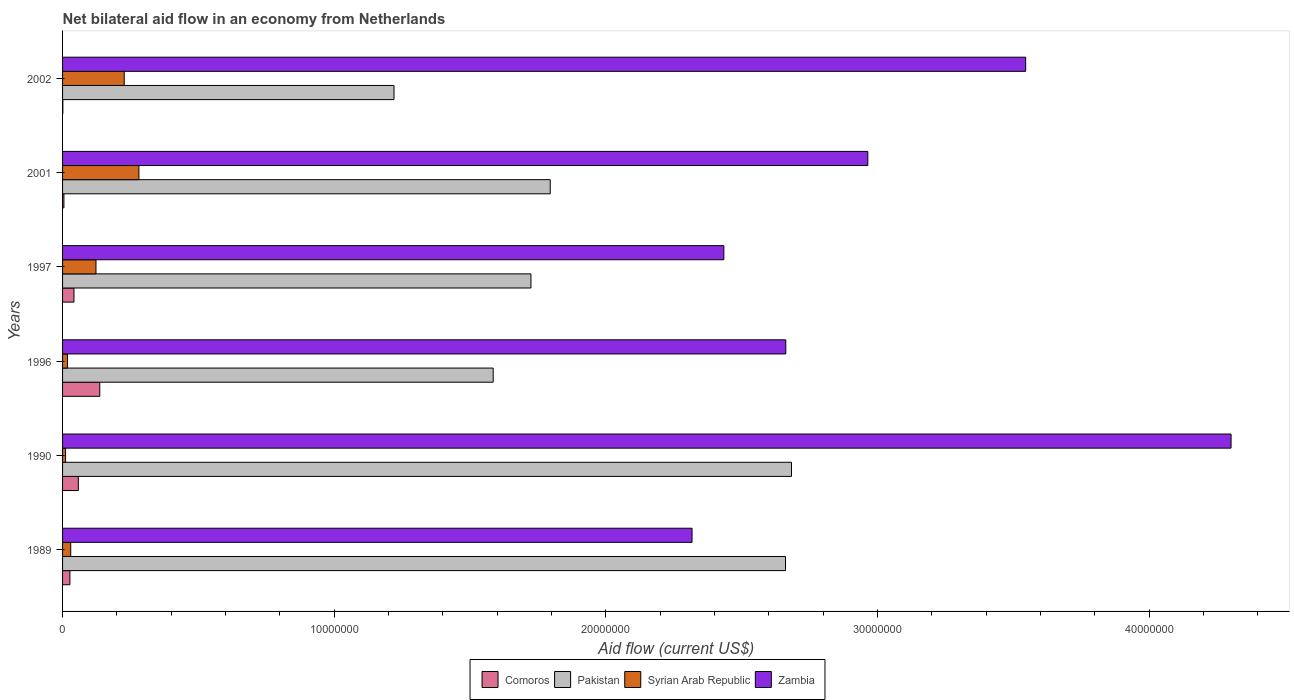How many different coloured bars are there?
Your answer should be very brief. 4. How many groups of bars are there?
Make the answer very short. 6. Are the number of bars per tick equal to the number of legend labels?
Ensure brevity in your answer.  Yes. Are the number of bars on each tick of the Y-axis equal?
Ensure brevity in your answer.  Yes. Across all years, what is the maximum net bilateral aid flow in Zambia?
Provide a succinct answer. 4.30e+07. In which year was the net bilateral aid flow in Syrian Arab Republic maximum?
Make the answer very short. 2001. What is the total net bilateral aid flow in Comoros in the graph?
Provide a short and direct response. 2.70e+06. What is the difference between the net bilateral aid flow in Zambia in 1990 and that in 2002?
Ensure brevity in your answer.  7.56e+06. What is the difference between the net bilateral aid flow in Zambia in 1997 and the net bilateral aid flow in Pakistan in 2001?
Provide a short and direct response. 6.39e+06. What is the average net bilateral aid flow in Comoros per year?
Provide a succinct answer. 4.50e+05. In the year 1989, what is the difference between the net bilateral aid flow in Pakistan and net bilateral aid flow in Syrian Arab Republic?
Make the answer very short. 2.63e+07. In how many years, is the net bilateral aid flow in Zambia greater than 30000000 US$?
Your response must be concise. 2. What is the ratio of the net bilateral aid flow in Comoros in 1990 to that in 1996?
Your answer should be very brief. 0.42. Is the net bilateral aid flow in Zambia in 1996 less than that in 2002?
Your answer should be compact. Yes. Is the difference between the net bilateral aid flow in Pakistan in 1997 and 2001 greater than the difference between the net bilateral aid flow in Syrian Arab Republic in 1997 and 2001?
Provide a short and direct response. Yes. What is the difference between the highest and the second highest net bilateral aid flow in Zambia?
Provide a short and direct response. 7.56e+06. What is the difference between the highest and the lowest net bilateral aid flow in Zambia?
Give a very brief answer. 1.98e+07. In how many years, is the net bilateral aid flow in Zambia greater than the average net bilateral aid flow in Zambia taken over all years?
Give a very brief answer. 2. Is it the case that in every year, the sum of the net bilateral aid flow in Pakistan and net bilateral aid flow in Zambia is greater than the sum of net bilateral aid flow in Comoros and net bilateral aid flow in Syrian Arab Republic?
Your response must be concise. Yes. What does the 2nd bar from the top in 2002 represents?
Offer a terse response. Syrian Arab Republic. What does the 1st bar from the bottom in 1996 represents?
Provide a succinct answer. Comoros. Is it the case that in every year, the sum of the net bilateral aid flow in Comoros and net bilateral aid flow in Zambia is greater than the net bilateral aid flow in Pakistan?
Offer a terse response. No. How many bars are there?
Provide a succinct answer. 24. Are all the bars in the graph horizontal?
Your answer should be very brief. Yes. How many years are there in the graph?
Give a very brief answer. 6. Does the graph contain any zero values?
Your answer should be very brief. No. Does the graph contain grids?
Offer a very short reply. No. Where does the legend appear in the graph?
Provide a short and direct response. Bottom center. What is the title of the graph?
Keep it short and to the point. Net bilateral aid flow in an economy from Netherlands. What is the label or title of the X-axis?
Offer a terse response. Aid flow (current US$). What is the Aid flow (current US$) in Pakistan in 1989?
Provide a succinct answer. 2.66e+07. What is the Aid flow (current US$) of Zambia in 1989?
Offer a very short reply. 2.32e+07. What is the Aid flow (current US$) in Comoros in 1990?
Keep it short and to the point. 5.80e+05. What is the Aid flow (current US$) of Pakistan in 1990?
Your response must be concise. 2.68e+07. What is the Aid flow (current US$) of Syrian Arab Republic in 1990?
Your answer should be compact. 1.10e+05. What is the Aid flow (current US$) of Zambia in 1990?
Give a very brief answer. 4.30e+07. What is the Aid flow (current US$) of Comoros in 1996?
Provide a succinct answer. 1.37e+06. What is the Aid flow (current US$) in Pakistan in 1996?
Offer a terse response. 1.58e+07. What is the Aid flow (current US$) in Syrian Arab Republic in 1996?
Keep it short and to the point. 1.80e+05. What is the Aid flow (current US$) of Zambia in 1996?
Your answer should be compact. 2.66e+07. What is the Aid flow (current US$) of Pakistan in 1997?
Offer a very short reply. 1.72e+07. What is the Aid flow (current US$) of Syrian Arab Republic in 1997?
Make the answer very short. 1.23e+06. What is the Aid flow (current US$) of Zambia in 1997?
Make the answer very short. 2.43e+07. What is the Aid flow (current US$) of Pakistan in 2001?
Your answer should be compact. 1.80e+07. What is the Aid flow (current US$) in Syrian Arab Republic in 2001?
Your answer should be very brief. 2.81e+06. What is the Aid flow (current US$) of Zambia in 2001?
Provide a succinct answer. 2.96e+07. What is the Aid flow (current US$) in Pakistan in 2002?
Give a very brief answer. 1.22e+07. What is the Aid flow (current US$) of Syrian Arab Republic in 2002?
Keep it short and to the point. 2.27e+06. What is the Aid flow (current US$) of Zambia in 2002?
Your answer should be compact. 3.54e+07. Across all years, what is the maximum Aid flow (current US$) in Comoros?
Provide a short and direct response. 1.37e+06. Across all years, what is the maximum Aid flow (current US$) in Pakistan?
Your answer should be compact. 2.68e+07. Across all years, what is the maximum Aid flow (current US$) in Syrian Arab Republic?
Provide a succinct answer. 2.81e+06. Across all years, what is the maximum Aid flow (current US$) of Zambia?
Keep it short and to the point. 4.30e+07. Across all years, what is the minimum Aid flow (current US$) in Comoros?
Offer a terse response. 10000. Across all years, what is the minimum Aid flow (current US$) in Pakistan?
Provide a short and direct response. 1.22e+07. Across all years, what is the minimum Aid flow (current US$) of Zambia?
Provide a short and direct response. 2.32e+07. What is the total Aid flow (current US$) of Comoros in the graph?
Your answer should be compact. 2.70e+06. What is the total Aid flow (current US$) in Pakistan in the graph?
Provide a succinct answer. 1.17e+08. What is the total Aid flow (current US$) in Syrian Arab Republic in the graph?
Ensure brevity in your answer.  6.90e+06. What is the total Aid flow (current US$) of Zambia in the graph?
Offer a terse response. 1.82e+08. What is the difference between the Aid flow (current US$) of Comoros in 1989 and that in 1990?
Provide a short and direct response. -3.10e+05. What is the difference between the Aid flow (current US$) in Pakistan in 1989 and that in 1990?
Keep it short and to the point. -2.20e+05. What is the difference between the Aid flow (current US$) in Syrian Arab Republic in 1989 and that in 1990?
Your answer should be very brief. 1.90e+05. What is the difference between the Aid flow (current US$) in Zambia in 1989 and that in 1990?
Offer a very short reply. -1.98e+07. What is the difference between the Aid flow (current US$) in Comoros in 1989 and that in 1996?
Your answer should be compact. -1.10e+06. What is the difference between the Aid flow (current US$) in Pakistan in 1989 and that in 1996?
Provide a short and direct response. 1.08e+07. What is the difference between the Aid flow (current US$) of Syrian Arab Republic in 1989 and that in 1996?
Your answer should be very brief. 1.20e+05. What is the difference between the Aid flow (current US$) in Zambia in 1989 and that in 1996?
Offer a very short reply. -3.45e+06. What is the difference between the Aid flow (current US$) of Pakistan in 1989 and that in 1997?
Offer a very short reply. 9.37e+06. What is the difference between the Aid flow (current US$) of Syrian Arab Republic in 1989 and that in 1997?
Your response must be concise. -9.30e+05. What is the difference between the Aid flow (current US$) of Zambia in 1989 and that in 1997?
Make the answer very short. -1.17e+06. What is the difference between the Aid flow (current US$) in Pakistan in 1989 and that in 2001?
Provide a short and direct response. 8.66e+06. What is the difference between the Aid flow (current US$) of Syrian Arab Republic in 1989 and that in 2001?
Your response must be concise. -2.51e+06. What is the difference between the Aid flow (current US$) of Zambia in 1989 and that in 2001?
Offer a very short reply. -6.47e+06. What is the difference between the Aid flow (current US$) in Pakistan in 1989 and that in 2002?
Ensure brevity in your answer.  1.44e+07. What is the difference between the Aid flow (current US$) in Syrian Arab Republic in 1989 and that in 2002?
Make the answer very short. -1.97e+06. What is the difference between the Aid flow (current US$) in Zambia in 1989 and that in 2002?
Ensure brevity in your answer.  -1.23e+07. What is the difference between the Aid flow (current US$) of Comoros in 1990 and that in 1996?
Make the answer very short. -7.90e+05. What is the difference between the Aid flow (current US$) in Pakistan in 1990 and that in 1996?
Provide a succinct answer. 1.10e+07. What is the difference between the Aid flow (current US$) of Syrian Arab Republic in 1990 and that in 1996?
Your response must be concise. -7.00e+04. What is the difference between the Aid flow (current US$) in Zambia in 1990 and that in 1996?
Provide a succinct answer. 1.64e+07. What is the difference between the Aid flow (current US$) of Comoros in 1990 and that in 1997?
Offer a terse response. 1.60e+05. What is the difference between the Aid flow (current US$) of Pakistan in 1990 and that in 1997?
Give a very brief answer. 9.59e+06. What is the difference between the Aid flow (current US$) of Syrian Arab Republic in 1990 and that in 1997?
Your response must be concise. -1.12e+06. What is the difference between the Aid flow (current US$) of Zambia in 1990 and that in 1997?
Offer a terse response. 1.87e+07. What is the difference between the Aid flow (current US$) of Comoros in 1990 and that in 2001?
Make the answer very short. 5.30e+05. What is the difference between the Aid flow (current US$) of Pakistan in 1990 and that in 2001?
Offer a very short reply. 8.88e+06. What is the difference between the Aid flow (current US$) of Syrian Arab Republic in 1990 and that in 2001?
Provide a short and direct response. -2.70e+06. What is the difference between the Aid flow (current US$) of Zambia in 1990 and that in 2001?
Ensure brevity in your answer.  1.34e+07. What is the difference between the Aid flow (current US$) of Comoros in 1990 and that in 2002?
Offer a very short reply. 5.70e+05. What is the difference between the Aid flow (current US$) of Pakistan in 1990 and that in 2002?
Keep it short and to the point. 1.46e+07. What is the difference between the Aid flow (current US$) of Syrian Arab Republic in 1990 and that in 2002?
Provide a succinct answer. -2.16e+06. What is the difference between the Aid flow (current US$) of Zambia in 1990 and that in 2002?
Give a very brief answer. 7.56e+06. What is the difference between the Aid flow (current US$) in Comoros in 1996 and that in 1997?
Make the answer very short. 9.50e+05. What is the difference between the Aid flow (current US$) in Pakistan in 1996 and that in 1997?
Make the answer very short. -1.39e+06. What is the difference between the Aid flow (current US$) of Syrian Arab Republic in 1996 and that in 1997?
Offer a terse response. -1.05e+06. What is the difference between the Aid flow (current US$) in Zambia in 1996 and that in 1997?
Offer a very short reply. 2.28e+06. What is the difference between the Aid flow (current US$) of Comoros in 1996 and that in 2001?
Your answer should be very brief. 1.32e+06. What is the difference between the Aid flow (current US$) in Pakistan in 1996 and that in 2001?
Provide a short and direct response. -2.10e+06. What is the difference between the Aid flow (current US$) of Syrian Arab Republic in 1996 and that in 2001?
Your response must be concise. -2.63e+06. What is the difference between the Aid flow (current US$) in Zambia in 1996 and that in 2001?
Give a very brief answer. -3.02e+06. What is the difference between the Aid flow (current US$) in Comoros in 1996 and that in 2002?
Offer a terse response. 1.36e+06. What is the difference between the Aid flow (current US$) in Pakistan in 1996 and that in 2002?
Your response must be concise. 3.65e+06. What is the difference between the Aid flow (current US$) in Syrian Arab Republic in 1996 and that in 2002?
Your answer should be compact. -2.09e+06. What is the difference between the Aid flow (current US$) of Zambia in 1996 and that in 2002?
Ensure brevity in your answer.  -8.83e+06. What is the difference between the Aid flow (current US$) of Comoros in 1997 and that in 2001?
Offer a terse response. 3.70e+05. What is the difference between the Aid flow (current US$) in Pakistan in 1997 and that in 2001?
Ensure brevity in your answer.  -7.10e+05. What is the difference between the Aid flow (current US$) in Syrian Arab Republic in 1997 and that in 2001?
Your answer should be compact. -1.58e+06. What is the difference between the Aid flow (current US$) of Zambia in 1997 and that in 2001?
Your response must be concise. -5.30e+06. What is the difference between the Aid flow (current US$) in Comoros in 1997 and that in 2002?
Provide a short and direct response. 4.10e+05. What is the difference between the Aid flow (current US$) of Pakistan in 1997 and that in 2002?
Your answer should be compact. 5.04e+06. What is the difference between the Aid flow (current US$) of Syrian Arab Republic in 1997 and that in 2002?
Your answer should be compact. -1.04e+06. What is the difference between the Aid flow (current US$) of Zambia in 1997 and that in 2002?
Your answer should be compact. -1.11e+07. What is the difference between the Aid flow (current US$) of Comoros in 2001 and that in 2002?
Keep it short and to the point. 4.00e+04. What is the difference between the Aid flow (current US$) in Pakistan in 2001 and that in 2002?
Offer a terse response. 5.75e+06. What is the difference between the Aid flow (current US$) of Syrian Arab Republic in 2001 and that in 2002?
Make the answer very short. 5.40e+05. What is the difference between the Aid flow (current US$) of Zambia in 2001 and that in 2002?
Your answer should be very brief. -5.81e+06. What is the difference between the Aid flow (current US$) in Comoros in 1989 and the Aid flow (current US$) in Pakistan in 1990?
Provide a short and direct response. -2.66e+07. What is the difference between the Aid flow (current US$) of Comoros in 1989 and the Aid flow (current US$) of Zambia in 1990?
Your answer should be compact. -4.27e+07. What is the difference between the Aid flow (current US$) in Pakistan in 1989 and the Aid flow (current US$) in Syrian Arab Republic in 1990?
Provide a short and direct response. 2.65e+07. What is the difference between the Aid flow (current US$) of Pakistan in 1989 and the Aid flow (current US$) of Zambia in 1990?
Keep it short and to the point. -1.64e+07. What is the difference between the Aid flow (current US$) in Syrian Arab Republic in 1989 and the Aid flow (current US$) in Zambia in 1990?
Make the answer very short. -4.27e+07. What is the difference between the Aid flow (current US$) in Comoros in 1989 and the Aid flow (current US$) in Pakistan in 1996?
Give a very brief answer. -1.56e+07. What is the difference between the Aid flow (current US$) in Comoros in 1989 and the Aid flow (current US$) in Zambia in 1996?
Your answer should be compact. -2.64e+07. What is the difference between the Aid flow (current US$) of Pakistan in 1989 and the Aid flow (current US$) of Syrian Arab Republic in 1996?
Provide a short and direct response. 2.64e+07. What is the difference between the Aid flow (current US$) in Syrian Arab Republic in 1989 and the Aid flow (current US$) in Zambia in 1996?
Your response must be concise. -2.63e+07. What is the difference between the Aid flow (current US$) in Comoros in 1989 and the Aid flow (current US$) in Pakistan in 1997?
Your answer should be very brief. -1.70e+07. What is the difference between the Aid flow (current US$) of Comoros in 1989 and the Aid flow (current US$) of Syrian Arab Republic in 1997?
Ensure brevity in your answer.  -9.60e+05. What is the difference between the Aid flow (current US$) in Comoros in 1989 and the Aid flow (current US$) in Zambia in 1997?
Offer a terse response. -2.41e+07. What is the difference between the Aid flow (current US$) of Pakistan in 1989 and the Aid flow (current US$) of Syrian Arab Republic in 1997?
Ensure brevity in your answer.  2.54e+07. What is the difference between the Aid flow (current US$) of Pakistan in 1989 and the Aid flow (current US$) of Zambia in 1997?
Your answer should be very brief. 2.27e+06. What is the difference between the Aid flow (current US$) in Syrian Arab Republic in 1989 and the Aid flow (current US$) in Zambia in 1997?
Offer a terse response. -2.40e+07. What is the difference between the Aid flow (current US$) in Comoros in 1989 and the Aid flow (current US$) in Pakistan in 2001?
Provide a succinct answer. -1.77e+07. What is the difference between the Aid flow (current US$) in Comoros in 1989 and the Aid flow (current US$) in Syrian Arab Republic in 2001?
Your answer should be very brief. -2.54e+06. What is the difference between the Aid flow (current US$) in Comoros in 1989 and the Aid flow (current US$) in Zambia in 2001?
Make the answer very short. -2.94e+07. What is the difference between the Aid flow (current US$) in Pakistan in 1989 and the Aid flow (current US$) in Syrian Arab Republic in 2001?
Your answer should be compact. 2.38e+07. What is the difference between the Aid flow (current US$) of Pakistan in 1989 and the Aid flow (current US$) of Zambia in 2001?
Your answer should be compact. -3.03e+06. What is the difference between the Aid flow (current US$) in Syrian Arab Republic in 1989 and the Aid flow (current US$) in Zambia in 2001?
Offer a terse response. -2.93e+07. What is the difference between the Aid flow (current US$) in Comoros in 1989 and the Aid flow (current US$) in Pakistan in 2002?
Ensure brevity in your answer.  -1.19e+07. What is the difference between the Aid flow (current US$) in Comoros in 1989 and the Aid flow (current US$) in Zambia in 2002?
Ensure brevity in your answer.  -3.52e+07. What is the difference between the Aid flow (current US$) in Pakistan in 1989 and the Aid flow (current US$) in Syrian Arab Republic in 2002?
Ensure brevity in your answer.  2.43e+07. What is the difference between the Aid flow (current US$) of Pakistan in 1989 and the Aid flow (current US$) of Zambia in 2002?
Give a very brief answer. -8.84e+06. What is the difference between the Aid flow (current US$) of Syrian Arab Republic in 1989 and the Aid flow (current US$) of Zambia in 2002?
Make the answer very short. -3.52e+07. What is the difference between the Aid flow (current US$) of Comoros in 1990 and the Aid flow (current US$) of Pakistan in 1996?
Give a very brief answer. -1.53e+07. What is the difference between the Aid flow (current US$) in Comoros in 1990 and the Aid flow (current US$) in Syrian Arab Republic in 1996?
Provide a short and direct response. 4.00e+05. What is the difference between the Aid flow (current US$) in Comoros in 1990 and the Aid flow (current US$) in Zambia in 1996?
Offer a very short reply. -2.60e+07. What is the difference between the Aid flow (current US$) of Pakistan in 1990 and the Aid flow (current US$) of Syrian Arab Republic in 1996?
Provide a short and direct response. 2.66e+07. What is the difference between the Aid flow (current US$) in Pakistan in 1990 and the Aid flow (current US$) in Zambia in 1996?
Your answer should be very brief. 2.10e+05. What is the difference between the Aid flow (current US$) in Syrian Arab Republic in 1990 and the Aid flow (current US$) in Zambia in 1996?
Offer a terse response. -2.65e+07. What is the difference between the Aid flow (current US$) of Comoros in 1990 and the Aid flow (current US$) of Pakistan in 1997?
Offer a terse response. -1.67e+07. What is the difference between the Aid flow (current US$) of Comoros in 1990 and the Aid flow (current US$) of Syrian Arab Republic in 1997?
Provide a succinct answer. -6.50e+05. What is the difference between the Aid flow (current US$) of Comoros in 1990 and the Aid flow (current US$) of Zambia in 1997?
Keep it short and to the point. -2.38e+07. What is the difference between the Aid flow (current US$) in Pakistan in 1990 and the Aid flow (current US$) in Syrian Arab Republic in 1997?
Keep it short and to the point. 2.56e+07. What is the difference between the Aid flow (current US$) of Pakistan in 1990 and the Aid flow (current US$) of Zambia in 1997?
Ensure brevity in your answer.  2.49e+06. What is the difference between the Aid flow (current US$) in Syrian Arab Republic in 1990 and the Aid flow (current US$) in Zambia in 1997?
Keep it short and to the point. -2.42e+07. What is the difference between the Aid flow (current US$) of Comoros in 1990 and the Aid flow (current US$) of Pakistan in 2001?
Your response must be concise. -1.74e+07. What is the difference between the Aid flow (current US$) in Comoros in 1990 and the Aid flow (current US$) in Syrian Arab Republic in 2001?
Offer a very short reply. -2.23e+06. What is the difference between the Aid flow (current US$) of Comoros in 1990 and the Aid flow (current US$) of Zambia in 2001?
Your answer should be very brief. -2.91e+07. What is the difference between the Aid flow (current US$) in Pakistan in 1990 and the Aid flow (current US$) in Syrian Arab Republic in 2001?
Ensure brevity in your answer.  2.40e+07. What is the difference between the Aid flow (current US$) in Pakistan in 1990 and the Aid flow (current US$) in Zambia in 2001?
Provide a short and direct response. -2.81e+06. What is the difference between the Aid flow (current US$) of Syrian Arab Republic in 1990 and the Aid flow (current US$) of Zambia in 2001?
Make the answer very short. -2.95e+07. What is the difference between the Aid flow (current US$) of Comoros in 1990 and the Aid flow (current US$) of Pakistan in 2002?
Offer a terse response. -1.16e+07. What is the difference between the Aid flow (current US$) of Comoros in 1990 and the Aid flow (current US$) of Syrian Arab Republic in 2002?
Offer a terse response. -1.69e+06. What is the difference between the Aid flow (current US$) of Comoros in 1990 and the Aid flow (current US$) of Zambia in 2002?
Provide a short and direct response. -3.49e+07. What is the difference between the Aid flow (current US$) of Pakistan in 1990 and the Aid flow (current US$) of Syrian Arab Republic in 2002?
Ensure brevity in your answer.  2.46e+07. What is the difference between the Aid flow (current US$) in Pakistan in 1990 and the Aid flow (current US$) in Zambia in 2002?
Offer a very short reply. -8.62e+06. What is the difference between the Aid flow (current US$) in Syrian Arab Republic in 1990 and the Aid flow (current US$) in Zambia in 2002?
Provide a short and direct response. -3.53e+07. What is the difference between the Aid flow (current US$) of Comoros in 1996 and the Aid flow (current US$) of Pakistan in 1997?
Offer a very short reply. -1.59e+07. What is the difference between the Aid flow (current US$) in Comoros in 1996 and the Aid flow (current US$) in Zambia in 1997?
Your answer should be compact. -2.30e+07. What is the difference between the Aid flow (current US$) of Pakistan in 1996 and the Aid flow (current US$) of Syrian Arab Republic in 1997?
Your response must be concise. 1.46e+07. What is the difference between the Aid flow (current US$) in Pakistan in 1996 and the Aid flow (current US$) in Zambia in 1997?
Provide a short and direct response. -8.49e+06. What is the difference between the Aid flow (current US$) of Syrian Arab Republic in 1996 and the Aid flow (current US$) of Zambia in 1997?
Provide a short and direct response. -2.42e+07. What is the difference between the Aid flow (current US$) in Comoros in 1996 and the Aid flow (current US$) in Pakistan in 2001?
Ensure brevity in your answer.  -1.66e+07. What is the difference between the Aid flow (current US$) of Comoros in 1996 and the Aid flow (current US$) of Syrian Arab Republic in 2001?
Offer a very short reply. -1.44e+06. What is the difference between the Aid flow (current US$) of Comoros in 1996 and the Aid flow (current US$) of Zambia in 2001?
Your response must be concise. -2.83e+07. What is the difference between the Aid flow (current US$) in Pakistan in 1996 and the Aid flow (current US$) in Syrian Arab Republic in 2001?
Make the answer very short. 1.30e+07. What is the difference between the Aid flow (current US$) of Pakistan in 1996 and the Aid flow (current US$) of Zambia in 2001?
Provide a succinct answer. -1.38e+07. What is the difference between the Aid flow (current US$) of Syrian Arab Republic in 1996 and the Aid flow (current US$) of Zambia in 2001?
Offer a very short reply. -2.95e+07. What is the difference between the Aid flow (current US$) of Comoros in 1996 and the Aid flow (current US$) of Pakistan in 2002?
Offer a terse response. -1.08e+07. What is the difference between the Aid flow (current US$) in Comoros in 1996 and the Aid flow (current US$) in Syrian Arab Republic in 2002?
Your answer should be compact. -9.00e+05. What is the difference between the Aid flow (current US$) of Comoros in 1996 and the Aid flow (current US$) of Zambia in 2002?
Offer a terse response. -3.41e+07. What is the difference between the Aid flow (current US$) in Pakistan in 1996 and the Aid flow (current US$) in Syrian Arab Republic in 2002?
Your answer should be very brief. 1.36e+07. What is the difference between the Aid flow (current US$) in Pakistan in 1996 and the Aid flow (current US$) in Zambia in 2002?
Make the answer very short. -1.96e+07. What is the difference between the Aid flow (current US$) of Syrian Arab Republic in 1996 and the Aid flow (current US$) of Zambia in 2002?
Make the answer very short. -3.53e+07. What is the difference between the Aid flow (current US$) of Comoros in 1997 and the Aid flow (current US$) of Pakistan in 2001?
Ensure brevity in your answer.  -1.75e+07. What is the difference between the Aid flow (current US$) of Comoros in 1997 and the Aid flow (current US$) of Syrian Arab Republic in 2001?
Give a very brief answer. -2.39e+06. What is the difference between the Aid flow (current US$) in Comoros in 1997 and the Aid flow (current US$) in Zambia in 2001?
Offer a terse response. -2.92e+07. What is the difference between the Aid flow (current US$) of Pakistan in 1997 and the Aid flow (current US$) of Syrian Arab Republic in 2001?
Offer a very short reply. 1.44e+07. What is the difference between the Aid flow (current US$) in Pakistan in 1997 and the Aid flow (current US$) in Zambia in 2001?
Make the answer very short. -1.24e+07. What is the difference between the Aid flow (current US$) in Syrian Arab Republic in 1997 and the Aid flow (current US$) in Zambia in 2001?
Provide a succinct answer. -2.84e+07. What is the difference between the Aid flow (current US$) in Comoros in 1997 and the Aid flow (current US$) in Pakistan in 2002?
Make the answer very short. -1.18e+07. What is the difference between the Aid flow (current US$) of Comoros in 1997 and the Aid flow (current US$) of Syrian Arab Republic in 2002?
Give a very brief answer. -1.85e+06. What is the difference between the Aid flow (current US$) in Comoros in 1997 and the Aid flow (current US$) in Zambia in 2002?
Keep it short and to the point. -3.50e+07. What is the difference between the Aid flow (current US$) in Pakistan in 1997 and the Aid flow (current US$) in Syrian Arab Republic in 2002?
Make the answer very short. 1.50e+07. What is the difference between the Aid flow (current US$) of Pakistan in 1997 and the Aid flow (current US$) of Zambia in 2002?
Your answer should be very brief. -1.82e+07. What is the difference between the Aid flow (current US$) of Syrian Arab Republic in 1997 and the Aid flow (current US$) of Zambia in 2002?
Give a very brief answer. -3.42e+07. What is the difference between the Aid flow (current US$) of Comoros in 2001 and the Aid flow (current US$) of Pakistan in 2002?
Ensure brevity in your answer.  -1.22e+07. What is the difference between the Aid flow (current US$) of Comoros in 2001 and the Aid flow (current US$) of Syrian Arab Republic in 2002?
Your response must be concise. -2.22e+06. What is the difference between the Aid flow (current US$) of Comoros in 2001 and the Aid flow (current US$) of Zambia in 2002?
Offer a terse response. -3.54e+07. What is the difference between the Aid flow (current US$) in Pakistan in 2001 and the Aid flow (current US$) in Syrian Arab Republic in 2002?
Ensure brevity in your answer.  1.57e+07. What is the difference between the Aid flow (current US$) of Pakistan in 2001 and the Aid flow (current US$) of Zambia in 2002?
Provide a succinct answer. -1.75e+07. What is the difference between the Aid flow (current US$) in Syrian Arab Republic in 2001 and the Aid flow (current US$) in Zambia in 2002?
Your answer should be very brief. -3.26e+07. What is the average Aid flow (current US$) in Comoros per year?
Offer a very short reply. 4.50e+05. What is the average Aid flow (current US$) of Pakistan per year?
Provide a short and direct response. 1.94e+07. What is the average Aid flow (current US$) of Syrian Arab Republic per year?
Provide a short and direct response. 1.15e+06. What is the average Aid flow (current US$) of Zambia per year?
Provide a succinct answer. 3.04e+07. In the year 1989, what is the difference between the Aid flow (current US$) of Comoros and Aid flow (current US$) of Pakistan?
Your response must be concise. -2.63e+07. In the year 1989, what is the difference between the Aid flow (current US$) in Comoros and Aid flow (current US$) in Syrian Arab Republic?
Provide a succinct answer. -3.00e+04. In the year 1989, what is the difference between the Aid flow (current US$) in Comoros and Aid flow (current US$) in Zambia?
Offer a terse response. -2.29e+07. In the year 1989, what is the difference between the Aid flow (current US$) in Pakistan and Aid flow (current US$) in Syrian Arab Republic?
Make the answer very short. 2.63e+07. In the year 1989, what is the difference between the Aid flow (current US$) of Pakistan and Aid flow (current US$) of Zambia?
Offer a terse response. 3.44e+06. In the year 1989, what is the difference between the Aid flow (current US$) of Syrian Arab Republic and Aid flow (current US$) of Zambia?
Offer a terse response. -2.29e+07. In the year 1990, what is the difference between the Aid flow (current US$) of Comoros and Aid flow (current US$) of Pakistan?
Give a very brief answer. -2.62e+07. In the year 1990, what is the difference between the Aid flow (current US$) in Comoros and Aid flow (current US$) in Zambia?
Give a very brief answer. -4.24e+07. In the year 1990, what is the difference between the Aid flow (current US$) of Pakistan and Aid flow (current US$) of Syrian Arab Republic?
Provide a succinct answer. 2.67e+07. In the year 1990, what is the difference between the Aid flow (current US$) of Pakistan and Aid flow (current US$) of Zambia?
Ensure brevity in your answer.  -1.62e+07. In the year 1990, what is the difference between the Aid flow (current US$) in Syrian Arab Republic and Aid flow (current US$) in Zambia?
Your answer should be very brief. -4.29e+07. In the year 1996, what is the difference between the Aid flow (current US$) of Comoros and Aid flow (current US$) of Pakistan?
Offer a very short reply. -1.45e+07. In the year 1996, what is the difference between the Aid flow (current US$) of Comoros and Aid flow (current US$) of Syrian Arab Republic?
Your answer should be compact. 1.19e+06. In the year 1996, what is the difference between the Aid flow (current US$) in Comoros and Aid flow (current US$) in Zambia?
Your answer should be compact. -2.52e+07. In the year 1996, what is the difference between the Aid flow (current US$) in Pakistan and Aid flow (current US$) in Syrian Arab Republic?
Keep it short and to the point. 1.57e+07. In the year 1996, what is the difference between the Aid flow (current US$) in Pakistan and Aid flow (current US$) in Zambia?
Provide a short and direct response. -1.08e+07. In the year 1996, what is the difference between the Aid flow (current US$) of Syrian Arab Republic and Aid flow (current US$) of Zambia?
Provide a succinct answer. -2.64e+07. In the year 1997, what is the difference between the Aid flow (current US$) of Comoros and Aid flow (current US$) of Pakistan?
Provide a short and direct response. -1.68e+07. In the year 1997, what is the difference between the Aid flow (current US$) of Comoros and Aid flow (current US$) of Syrian Arab Republic?
Provide a short and direct response. -8.10e+05. In the year 1997, what is the difference between the Aid flow (current US$) of Comoros and Aid flow (current US$) of Zambia?
Ensure brevity in your answer.  -2.39e+07. In the year 1997, what is the difference between the Aid flow (current US$) of Pakistan and Aid flow (current US$) of Syrian Arab Republic?
Make the answer very short. 1.60e+07. In the year 1997, what is the difference between the Aid flow (current US$) in Pakistan and Aid flow (current US$) in Zambia?
Offer a terse response. -7.10e+06. In the year 1997, what is the difference between the Aid flow (current US$) of Syrian Arab Republic and Aid flow (current US$) of Zambia?
Make the answer very short. -2.31e+07. In the year 2001, what is the difference between the Aid flow (current US$) of Comoros and Aid flow (current US$) of Pakistan?
Make the answer very short. -1.79e+07. In the year 2001, what is the difference between the Aid flow (current US$) in Comoros and Aid flow (current US$) in Syrian Arab Republic?
Your answer should be compact. -2.76e+06. In the year 2001, what is the difference between the Aid flow (current US$) of Comoros and Aid flow (current US$) of Zambia?
Provide a succinct answer. -2.96e+07. In the year 2001, what is the difference between the Aid flow (current US$) of Pakistan and Aid flow (current US$) of Syrian Arab Republic?
Provide a short and direct response. 1.51e+07. In the year 2001, what is the difference between the Aid flow (current US$) of Pakistan and Aid flow (current US$) of Zambia?
Provide a short and direct response. -1.17e+07. In the year 2001, what is the difference between the Aid flow (current US$) of Syrian Arab Republic and Aid flow (current US$) of Zambia?
Keep it short and to the point. -2.68e+07. In the year 2002, what is the difference between the Aid flow (current US$) in Comoros and Aid flow (current US$) in Pakistan?
Provide a succinct answer. -1.22e+07. In the year 2002, what is the difference between the Aid flow (current US$) of Comoros and Aid flow (current US$) of Syrian Arab Republic?
Give a very brief answer. -2.26e+06. In the year 2002, what is the difference between the Aid flow (current US$) in Comoros and Aid flow (current US$) in Zambia?
Provide a short and direct response. -3.54e+07. In the year 2002, what is the difference between the Aid flow (current US$) in Pakistan and Aid flow (current US$) in Syrian Arab Republic?
Keep it short and to the point. 9.93e+06. In the year 2002, what is the difference between the Aid flow (current US$) of Pakistan and Aid flow (current US$) of Zambia?
Your response must be concise. -2.32e+07. In the year 2002, what is the difference between the Aid flow (current US$) of Syrian Arab Republic and Aid flow (current US$) of Zambia?
Your response must be concise. -3.32e+07. What is the ratio of the Aid flow (current US$) of Comoros in 1989 to that in 1990?
Make the answer very short. 0.47. What is the ratio of the Aid flow (current US$) in Pakistan in 1989 to that in 1990?
Make the answer very short. 0.99. What is the ratio of the Aid flow (current US$) of Syrian Arab Republic in 1989 to that in 1990?
Give a very brief answer. 2.73. What is the ratio of the Aid flow (current US$) of Zambia in 1989 to that in 1990?
Offer a very short reply. 0.54. What is the ratio of the Aid flow (current US$) of Comoros in 1989 to that in 1996?
Your response must be concise. 0.2. What is the ratio of the Aid flow (current US$) in Pakistan in 1989 to that in 1996?
Provide a succinct answer. 1.68. What is the ratio of the Aid flow (current US$) of Syrian Arab Republic in 1989 to that in 1996?
Ensure brevity in your answer.  1.67. What is the ratio of the Aid flow (current US$) in Zambia in 1989 to that in 1996?
Offer a terse response. 0.87. What is the ratio of the Aid flow (current US$) in Comoros in 1989 to that in 1997?
Your answer should be compact. 0.64. What is the ratio of the Aid flow (current US$) of Pakistan in 1989 to that in 1997?
Offer a terse response. 1.54. What is the ratio of the Aid flow (current US$) of Syrian Arab Republic in 1989 to that in 1997?
Offer a terse response. 0.24. What is the ratio of the Aid flow (current US$) in Zambia in 1989 to that in 1997?
Provide a short and direct response. 0.95. What is the ratio of the Aid flow (current US$) of Comoros in 1989 to that in 2001?
Give a very brief answer. 5.4. What is the ratio of the Aid flow (current US$) of Pakistan in 1989 to that in 2001?
Your response must be concise. 1.48. What is the ratio of the Aid flow (current US$) in Syrian Arab Republic in 1989 to that in 2001?
Make the answer very short. 0.11. What is the ratio of the Aid flow (current US$) in Zambia in 1989 to that in 2001?
Provide a short and direct response. 0.78. What is the ratio of the Aid flow (current US$) in Comoros in 1989 to that in 2002?
Make the answer very short. 27. What is the ratio of the Aid flow (current US$) in Pakistan in 1989 to that in 2002?
Offer a very short reply. 2.18. What is the ratio of the Aid flow (current US$) of Syrian Arab Republic in 1989 to that in 2002?
Provide a succinct answer. 0.13. What is the ratio of the Aid flow (current US$) of Zambia in 1989 to that in 2002?
Provide a succinct answer. 0.65. What is the ratio of the Aid flow (current US$) of Comoros in 1990 to that in 1996?
Provide a succinct answer. 0.42. What is the ratio of the Aid flow (current US$) in Pakistan in 1990 to that in 1996?
Your answer should be very brief. 1.69. What is the ratio of the Aid flow (current US$) of Syrian Arab Republic in 1990 to that in 1996?
Give a very brief answer. 0.61. What is the ratio of the Aid flow (current US$) in Zambia in 1990 to that in 1996?
Your answer should be compact. 1.62. What is the ratio of the Aid flow (current US$) in Comoros in 1990 to that in 1997?
Offer a terse response. 1.38. What is the ratio of the Aid flow (current US$) of Pakistan in 1990 to that in 1997?
Provide a short and direct response. 1.56. What is the ratio of the Aid flow (current US$) of Syrian Arab Republic in 1990 to that in 1997?
Your response must be concise. 0.09. What is the ratio of the Aid flow (current US$) in Zambia in 1990 to that in 1997?
Ensure brevity in your answer.  1.77. What is the ratio of the Aid flow (current US$) in Pakistan in 1990 to that in 2001?
Offer a terse response. 1.49. What is the ratio of the Aid flow (current US$) in Syrian Arab Republic in 1990 to that in 2001?
Your answer should be compact. 0.04. What is the ratio of the Aid flow (current US$) in Zambia in 1990 to that in 2001?
Ensure brevity in your answer.  1.45. What is the ratio of the Aid flow (current US$) of Pakistan in 1990 to that in 2002?
Keep it short and to the point. 2.2. What is the ratio of the Aid flow (current US$) of Syrian Arab Republic in 1990 to that in 2002?
Your answer should be compact. 0.05. What is the ratio of the Aid flow (current US$) in Zambia in 1990 to that in 2002?
Ensure brevity in your answer.  1.21. What is the ratio of the Aid flow (current US$) of Comoros in 1996 to that in 1997?
Make the answer very short. 3.26. What is the ratio of the Aid flow (current US$) in Pakistan in 1996 to that in 1997?
Provide a short and direct response. 0.92. What is the ratio of the Aid flow (current US$) in Syrian Arab Republic in 1996 to that in 1997?
Ensure brevity in your answer.  0.15. What is the ratio of the Aid flow (current US$) of Zambia in 1996 to that in 1997?
Provide a succinct answer. 1.09. What is the ratio of the Aid flow (current US$) in Comoros in 1996 to that in 2001?
Make the answer very short. 27.4. What is the ratio of the Aid flow (current US$) of Pakistan in 1996 to that in 2001?
Provide a short and direct response. 0.88. What is the ratio of the Aid flow (current US$) in Syrian Arab Republic in 1996 to that in 2001?
Keep it short and to the point. 0.06. What is the ratio of the Aid flow (current US$) of Zambia in 1996 to that in 2001?
Your answer should be very brief. 0.9. What is the ratio of the Aid flow (current US$) of Comoros in 1996 to that in 2002?
Provide a short and direct response. 137. What is the ratio of the Aid flow (current US$) of Pakistan in 1996 to that in 2002?
Offer a very short reply. 1.3. What is the ratio of the Aid flow (current US$) in Syrian Arab Republic in 1996 to that in 2002?
Give a very brief answer. 0.08. What is the ratio of the Aid flow (current US$) of Zambia in 1996 to that in 2002?
Your response must be concise. 0.75. What is the ratio of the Aid flow (current US$) of Pakistan in 1997 to that in 2001?
Keep it short and to the point. 0.96. What is the ratio of the Aid flow (current US$) in Syrian Arab Republic in 1997 to that in 2001?
Your answer should be compact. 0.44. What is the ratio of the Aid flow (current US$) of Zambia in 1997 to that in 2001?
Provide a short and direct response. 0.82. What is the ratio of the Aid flow (current US$) of Comoros in 1997 to that in 2002?
Ensure brevity in your answer.  42. What is the ratio of the Aid flow (current US$) of Pakistan in 1997 to that in 2002?
Your answer should be very brief. 1.41. What is the ratio of the Aid flow (current US$) of Syrian Arab Republic in 1997 to that in 2002?
Your answer should be compact. 0.54. What is the ratio of the Aid flow (current US$) of Zambia in 1997 to that in 2002?
Offer a very short reply. 0.69. What is the ratio of the Aid flow (current US$) in Comoros in 2001 to that in 2002?
Provide a short and direct response. 5. What is the ratio of the Aid flow (current US$) in Pakistan in 2001 to that in 2002?
Provide a short and direct response. 1.47. What is the ratio of the Aid flow (current US$) of Syrian Arab Republic in 2001 to that in 2002?
Provide a succinct answer. 1.24. What is the ratio of the Aid flow (current US$) of Zambia in 2001 to that in 2002?
Ensure brevity in your answer.  0.84. What is the difference between the highest and the second highest Aid flow (current US$) of Comoros?
Offer a very short reply. 7.90e+05. What is the difference between the highest and the second highest Aid flow (current US$) of Syrian Arab Republic?
Your response must be concise. 5.40e+05. What is the difference between the highest and the second highest Aid flow (current US$) in Zambia?
Your answer should be very brief. 7.56e+06. What is the difference between the highest and the lowest Aid flow (current US$) of Comoros?
Ensure brevity in your answer.  1.36e+06. What is the difference between the highest and the lowest Aid flow (current US$) of Pakistan?
Offer a very short reply. 1.46e+07. What is the difference between the highest and the lowest Aid flow (current US$) of Syrian Arab Republic?
Provide a succinct answer. 2.70e+06. What is the difference between the highest and the lowest Aid flow (current US$) of Zambia?
Your response must be concise. 1.98e+07. 